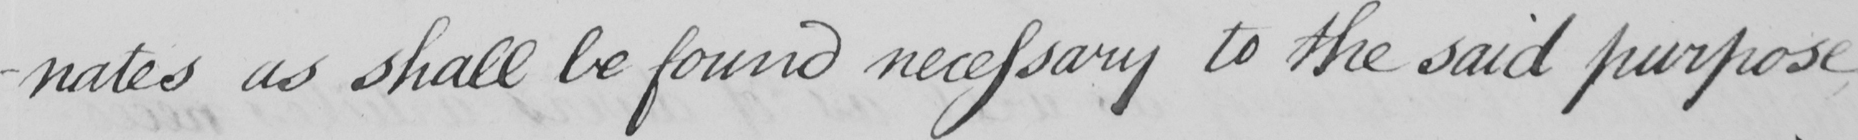Can you tell me what this handwritten text says? -nates as shall be found necessary to the said purpose 